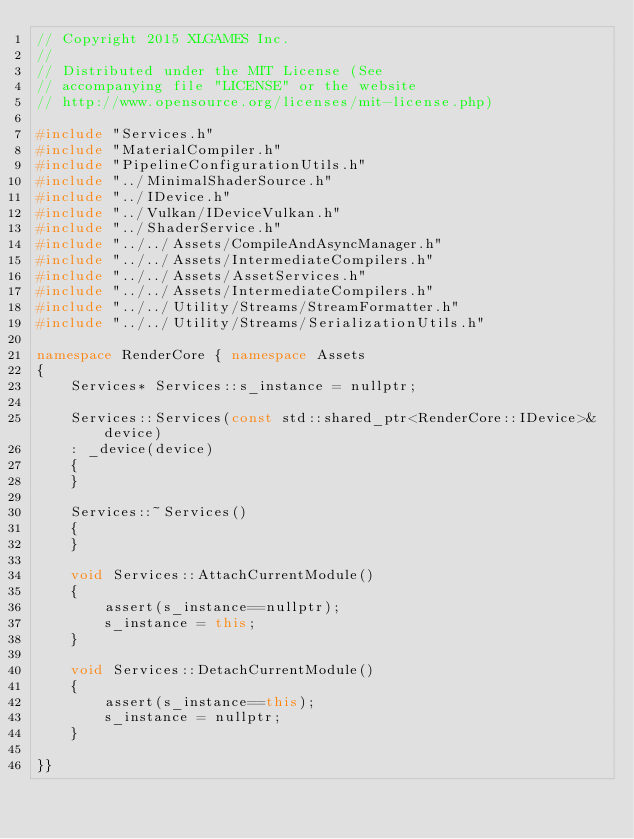<code> <loc_0><loc_0><loc_500><loc_500><_C++_>// Copyright 2015 XLGAMES Inc.
//
// Distributed under the MIT License (See
// accompanying file "LICENSE" or the website
// http://www.opensource.org/licenses/mit-license.php)

#include "Services.h"
#include "MaterialCompiler.h"
#include "PipelineConfigurationUtils.h"
#include "../MinimalShaderSource.h"
#include "../IDevice.h"
#include "../Vulkan/IDeviceVulkan.h"
#include "../ShaderService.h"
#include "../../Assets/CompileAndAsyncManager.h"
#include "../../Assets/IntermediateCompilers.h"
#include "../../Assets/AssetServices.h"
#include "../../Assets/IntermediateCompilers.h"
#include "../../Utility/Streams/StreamFormatter.h"
#include "../../Utility/Streams/SerializationUtils.h"

namespace RenderCore { namespace Assets
{
    Services* Services::s_instance = nullptr;

    Services::Services(const std::shared_ptr<RenderCore::IDevice>& device)
    : _device(device)
    {
    }

    Services::~Services()
    {
    }

    void Services::AttachCurrentModule()
    {
        assert(s_instance==nullptr);
        s_instance = this;
    }

    void Services::DetachCurrentModule()
    {
        assert(s_instance==this);
        s_instance = nullptr;
    }

}}

</code> 